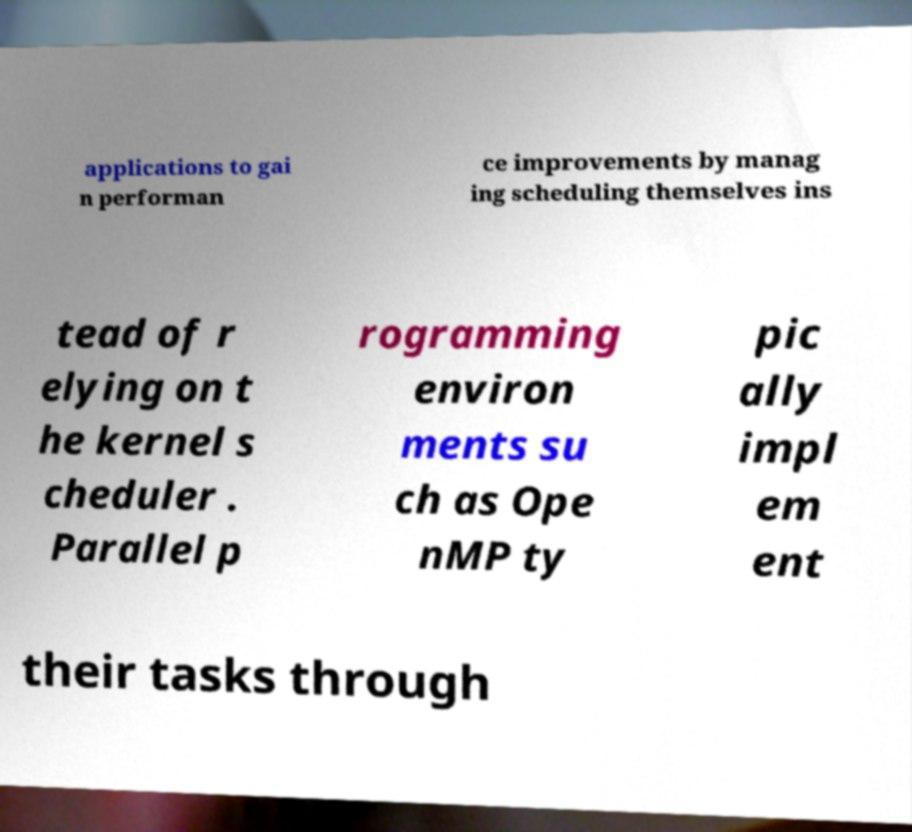Could you assist in decoding the text presented in this image and type it out clearly? applications to gai n performan ce improvements by manag ing scheduling themselves ins tead of r elying on t he kernel s cheduler . Parallel p rogramming environ ments su ch as Ope nMP ty pic ally impl em ent their tasks through 